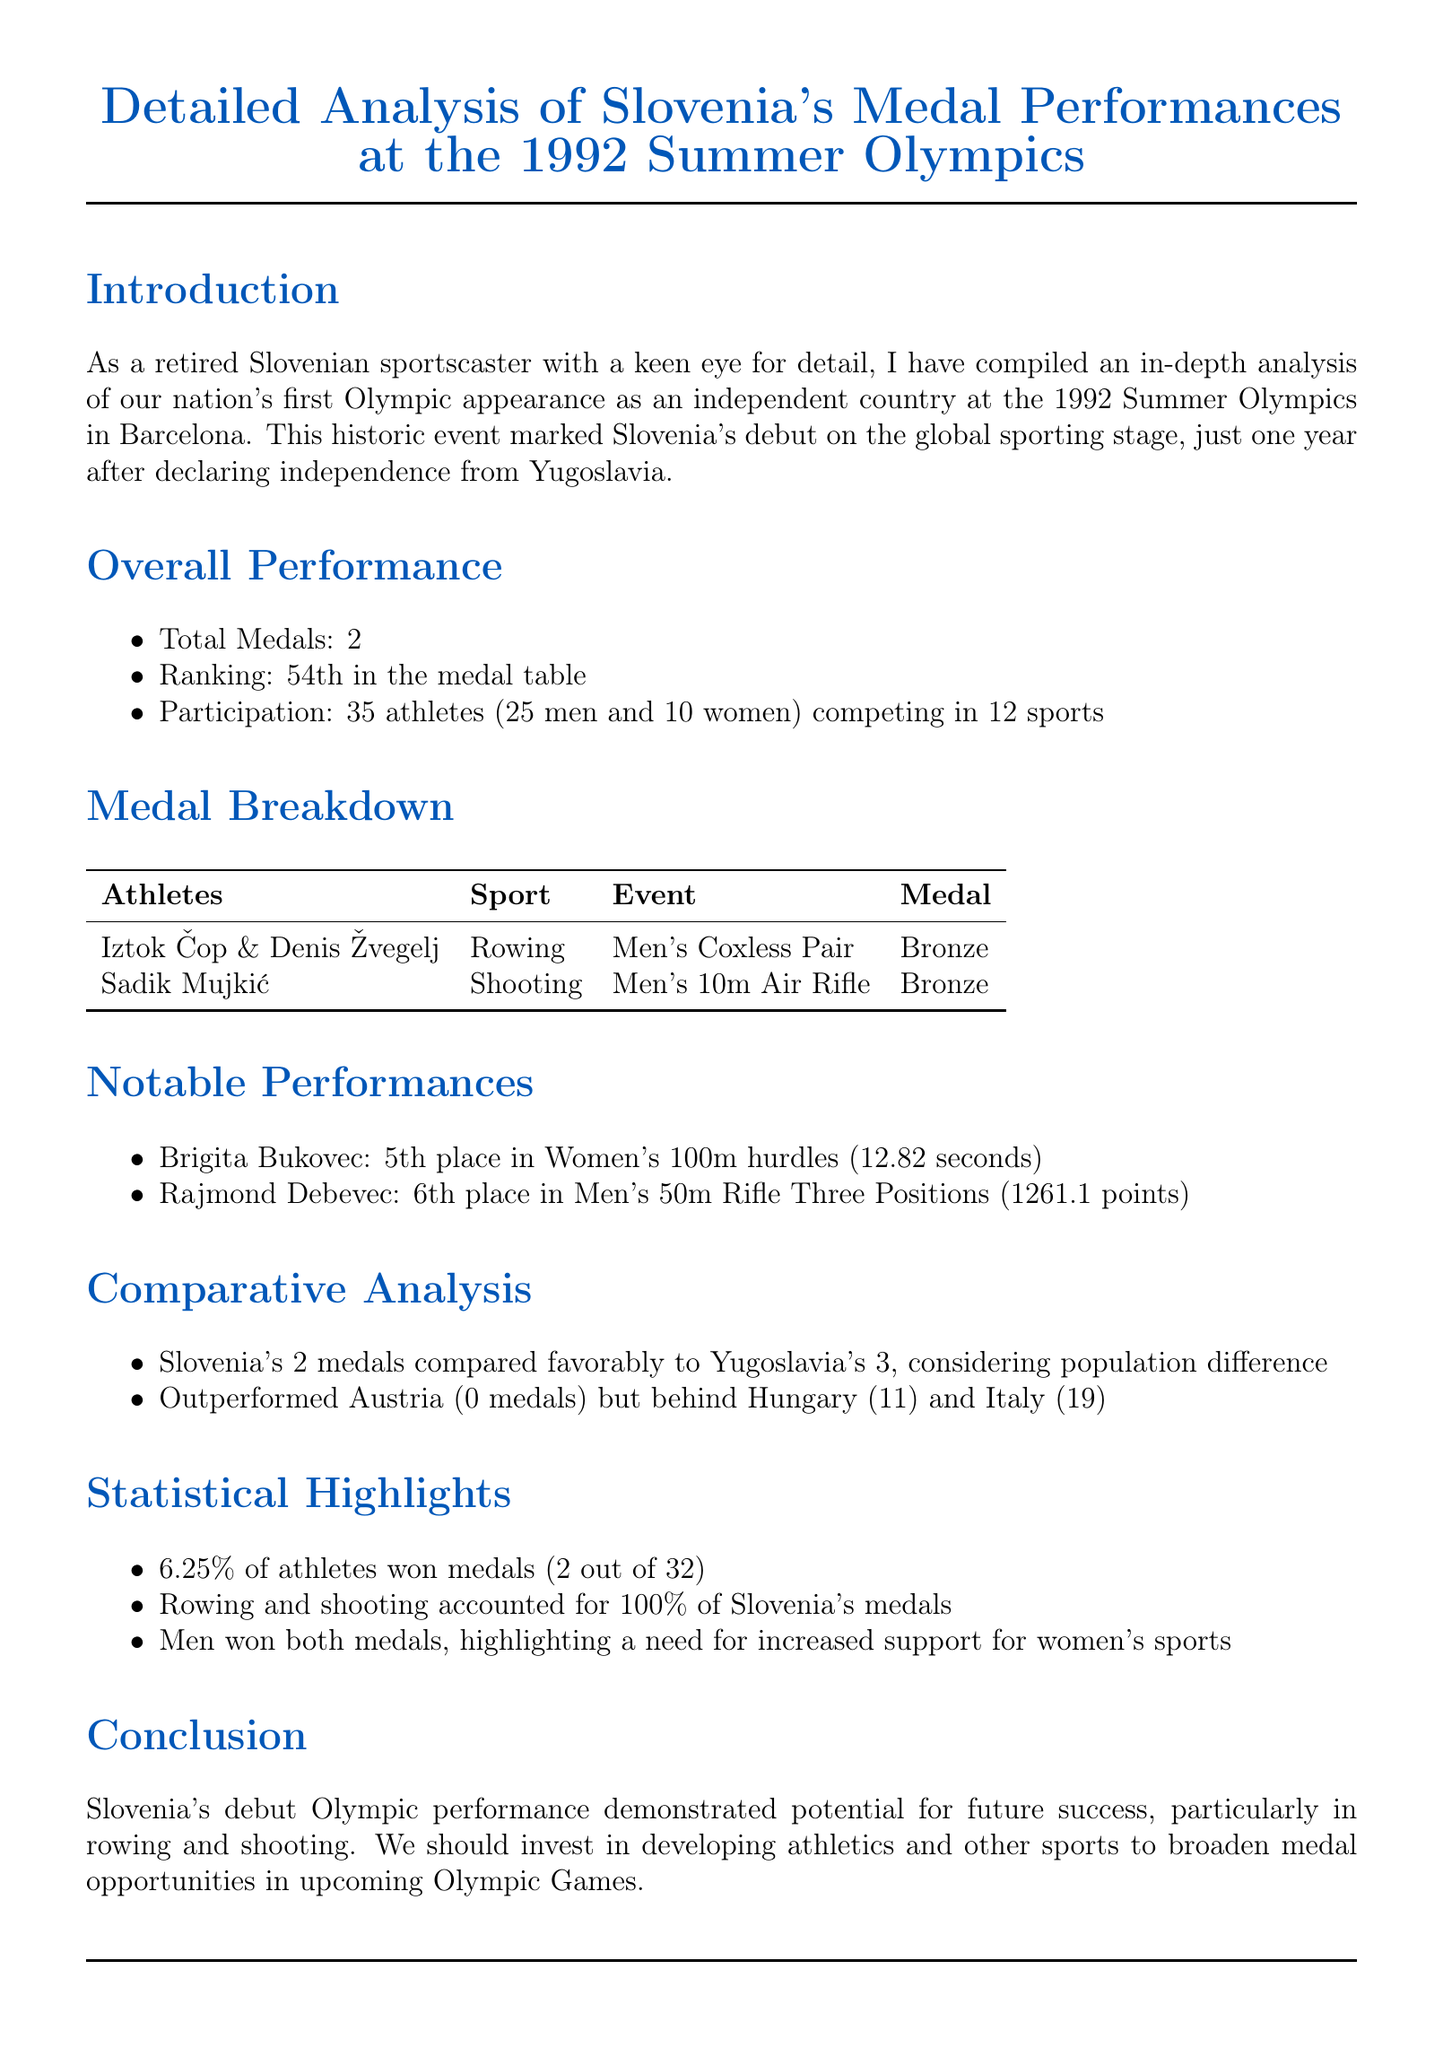What was the title of the memo? The title summarizes the document's focus on Slovenia's Olympic performances at a specific event, which is the 1992 Summer Olympics.
Answer: Detailed Analysis of Slovenia's Medal Performances at the 1992 Summer Olympics How many total medals did Slovenia win? The overall performance section clearly states the total number of medals won by Slovenia at the Olympics.
Answer: 2 Who won the bronze medal in rowing? The medal breakdown specifies the athletes who contributed to Slovenia's medals, including the rowing event.
Answer: Iztok Čop and Denis Žvegelj What position did Brigita Bukovec finish in her event? The notable performances section indicates the placement of athletes, including Brigita Bukovec's outcome.
Answer: 5th place Which sport accounted for both of Slovenia's medals? The statistical highlights describe which sports led to medal achievements for Slovenia at these Olympics.
Answer: Rowing and shooting What was Slovenia's ranking in the medal table? The overall performance section directly mentions Slovenia’s ranking based on their total medal count.
Answer: 54th in the medal table How many athletes comprised Slovenia's Olympic team? The document details the size of Slovenia's athlete representation at the Olympics, found in the overall performance section.
Answer: 35 athletes What was the percentage of athletes who won medals? The statistical highlights provide a specific statistic regarding the athletes’ performance in terms of medals won.
Answer: 6.25% How many sports did Slovenia compete in at the Olympics? The overall performance section lists the total number of sports in which Slovenian athletes participated.
Answer: 12 sports 